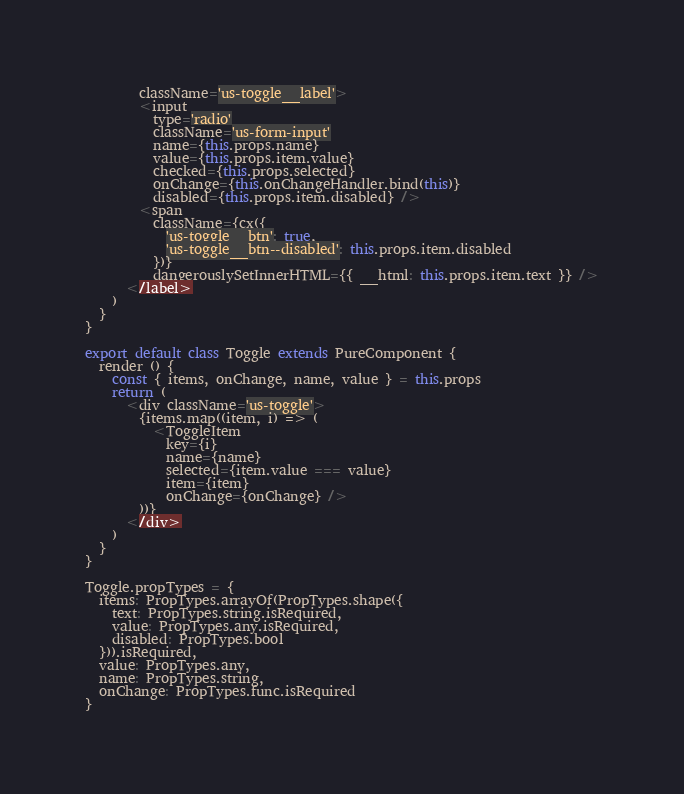<code> <loc_0><loc_0><loc_500><loc_500><_JavaScript_>        className='us-toggle__label'>
        <input
          type='radio'
          className='us-form-input'
          name={this.props.name}
          value={this.props.item.value}
          checked={this.props.selected}
          onChange={this.onChangeHandler.bind(this)}
          disabled={this.props.item.disabled} />
        <span
          className={cx({
            'us-toggle__btn': true,
            'us-toggle__btn--disabled': this.props.item.disabled
          })}
          dangerouslySetInnerHTML={{ __html: this.props.item.text }} />
      </label>
    )
  }
}

export default class Toggle extends PureComponent {
  render () {
    const { items, onChange, name, value } = this.props
    return (
      <div className='us-toggle'>
        {items.map((item, i) => (
          <ToggleItem
            key={i}
            name={name}
            selected={item.value === value}
            item={item}
            onChange={onChange} />
        ))}
      </div>
    )
  }
}

Toggle.propTypes = {
  items: PropTypes.arrayOf(PropTypes.shape({
    text: PropTypes.string.isRequired,
    value: PropTypes.any.isRequired,
    disabled: PropTypes.bool
  })).isRequired,
  value: PropTypes.any,
  name: PropTypes.string,
  onChange: PropTypes.func.isRequired
}
</code> 